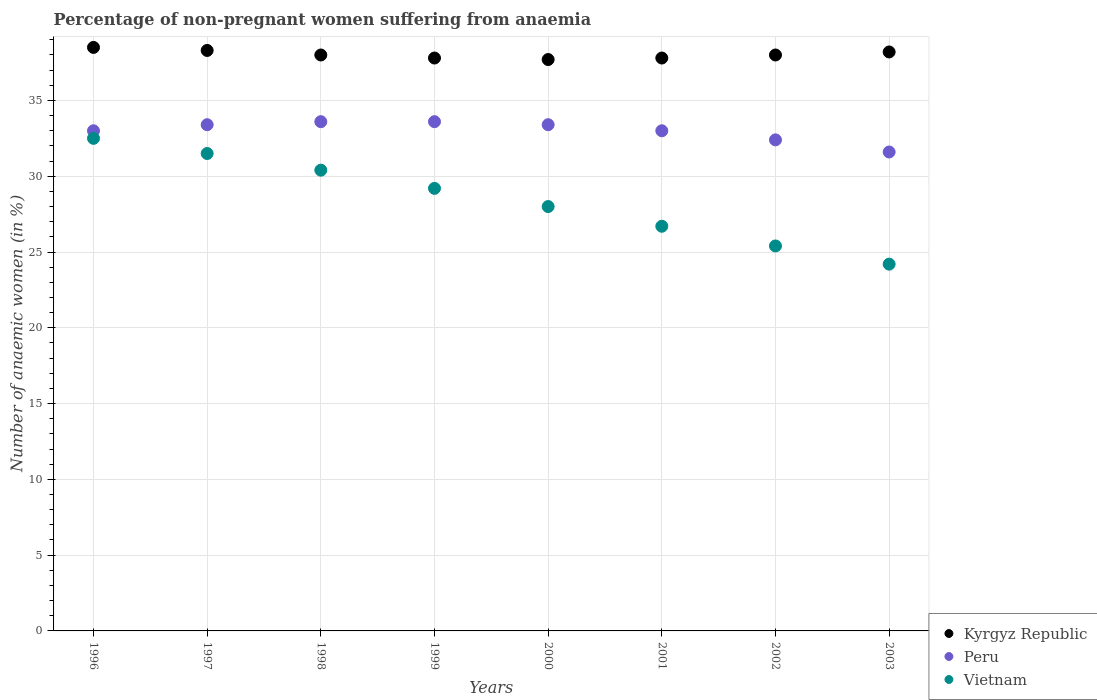How many different coloured dotlines are there?
Provide a succinct answer. 3. What is the percentage of non-pregnant women suffering from anaemia in Kyrgyz Republic in 1996?
Offer a very short reply. 38.5. Across all years, what is the maximum percentage of non-pregnant women suffering from anaemia in Kyrgyz Republic?
Provide a short and direct response. 38.5. Across all years, what is the minimum percentage of non-pregnant women suffering from anaemia in Peru?
Make the answer very short. 31.6. In which year was the percentage of non-pregnant women suffering from anaemia in Vietnam maximum?
Offer a very short reply. 1996. In which year was the percentage of non-pregnant women suffering from anaemia in Peru minimum?
Your answer should be very brief. 2003. What is the total percentage of non-pregnant women suffering from anaemia in Kyrgyz Republic in the graph?
Your answer should be very brief. 304.3. What is the difference between the percentage of non-pregnant women suffering from anaemia in Vietnam in 1998 and that in 2003?
Make the answer very short. 6.2. What is the average percentage of non-pregnant women suffering from anaemia in Kyrgyz Republic per year?
Your response must be concise. 38.04. In the year 1997, what is the difference between the percentage of non-pregnant women suffering from anaemia in Peru and percentage of non-pregnant women suffering from anaemia in Kyrgyz Republic?
Ensure brevity in your answer.  -4.9. In how many years, is the percentage of non-pregnant women suffering from anaemia in Kyrgyz Republic greater than 23 %?
Keep it short and to the point. 8. What is the ratio of the percentage of non-pregnant women suffering from anaemia in Peru in 2000 to that in 2001?
Your response must be concise. 1.01. Is the percentage of non-pregnant women suffering from anaemia in Kyrgyz Republic in 2001 less than that in 2002?
Your answer should be very brief. Yes. Is the difference between the percentage of non-pregnant women suffering from anaemia in Peru in 1997 and 2001 greater than the difference between the percentage of non-pregnant women suffering from anaemia in Kyrgyz Republic in 1997 and 2001?
Ensure brevity in your answer.  No. What is the difference between the highest and the second highest percentage of non-pregnant women suffering from anaemia in Kyrgyz Republic?
Provide a short and direct response. 0.2. What is the difference between the highest and the lowest percentage of non-pregnant women suffering from anaemia in Peru?
Ensure brevity in your answer.  2. In how many years, is the percentage of non-pregnant women suffering from anaemia in Peru greater than the average percentage of non-pregnant women suffering from anaemia in Peru taken over all years?
Provide a short and direct response. 4. Is it the case that in every year, the sum of the percentage of non-pregnant women suffering from anaemia in Peru and percentage of non-pregnant women suffering from anaemia in Vietnam  is greater than the percentage of non-pregnant women suffering from anaemia in Kyrgyz Republic?
Offer a terse response. Yes. Does the percentage of non-pregnant women suffering from anaemia in Peru monotonically increase over the years?
Your answer should be very brief. No. What is the difference between two consecutive major ticks on the Y-axis?
Offer a terse response. 5. Are the values on the major ticks of Y-axis written in scientific E-notation?
Offer a very short reply. No. Does the graph contain any zero values?
Offer a terse response. No. Does the graph contain grids?
Keep it short and to the point. Yes. Where does the legend appear in the graph?
Provide a succinct answer. Bottom right. How many legend labels are there?
Offer a very short reply. 3. What is the title of the graph?
Your answer should be compact. Percentage of non-pregnant women suffering from anaemia. What is the label or title of the X-axis?
Your response must be concise. Years. What is the label or title of the Y-axis?
Your response must be concise. Number of anaemic women (in %). What is the Number of anaemic women (in %) in Kyrgyz Republic in 1996?
Make the answer very short. 38.5. What is the Number of anaemic women (in %) of Vietnam in 1996?
Offer a terse response. 32.5. What is the Number of anaemic women (in %) in Kyrgyz Republic in 1997?
Offer a very short reply. 38.3. What is the Number of anaemic women (in %) of Peru in 1997?
Ensure brevity in your answer.  33.4. What is the Number of anaemic women (in %) in Vietnam in 1997?
Make the answer very short. 31.5. What is the Number of anaemic women (in %) in Peru in 1998?
Offer a very short reply. 33.6. What is the Number of anaemic women (in %) in Vietnam in 1998?
Provide a short and direct response. 30.4. What is the Number of anaemic women (in %) of Kyrgyz Republic in 1999?
Offer a terse response. 37.8. What is the Number of anaemic women (in %) in Peru in 1999?
Make the answer very short. 33.6. What is the Number of anaemic women (in %) in Vietnam in 1999?
Provide a succinct answer. 29.2. What is the Number of anaemic women (in %) of Kyrgyz Republic in 2000?
Your answer should be very brief. 37.7. What is the Number of anaemic women (in %) in Peru in 2000?
Your answer should be very brief. 33.4. What is the Number of anaemic women (in %) in Kyrgyz Republic in 2001?
Provide a short and direct response. 37.8. What is the Number of anaemic women (in %) of Peru in 2001?
Your response must be concise. 33. What is the Number of anaemic women (in %) of Vietnam in 2001?
Your response must be concise. 26.7. What is the Number of anaemic women (in %) of Kyrgyz Republic in 2002?
Give a very brief answer. 38. What is the Number of anaemic women (in %) of Peru in 2002?
Give a very brief answer. 32.4. What is the Number of anaemic women (in %) in Vietnam in 2002?
Provide a short and direct response. 25.4. What is the Number of anaemic women (in %) in Kyrgyz Republic in 2003?
Your answer should be compact. 38.2. What is the Number of anaemic women (in %) of Peru in 2003?
Offer a very short reply. 31.6. What is the Number of anaemic women (in %) of Vietnam in 2003?
Your answer should be very brief. 24.2. Across all years, what is the maximum Number of anaemic women (in %) of Kyrgyz Republic?
Make the answer very short. 38.5. Across all years, what is the maximum Number of anaemic women (in %) in Peru?
Provide a succinct answer. 33.6. Across all years, what is the maximum Number of anaemic women (in %) of Vietnam?
Give a very brief answer. 32.5. Across all years, what is the minimum Number of anaemic women (in %) in Kyrgyz Republic?
Make the answer very short. 37.7. Across all years, what is the minimum Number of anaemic women (in %) in Peru?
Provide a short and direct response. 31.6. Across all years, what is the minimum Number of anaemic women (in %) in Vietnam?
Give a very brief answer. 24.2. What is the total Number of anaemic women (in %) of Kyrgyz Republic in the graph?
Ensure brevity in your answer.  304.3. What is the total Number of anaemic women (in %) in Peru in the graph?
Make the answer very short. 264. What is the total Number of anaemic women (in %) in Vietnam in the graph?
Your answer should be compact. 227.9. What is the difference between the Number of anaemic women (in %) in Kyrgyz Republic in 1996 and that in 1997?
Your response must be concise. 0.2. What is the difference between the Number of anaemic women (in %) of Peru in 1996 and that in 1997?
Offer a terse response. -0.4. What is the difference between the Number of anaemic women (in %) in Vietnam in 1996 and that in 1999?
Keep it short and to the point. 3.3. What is the difference between the Number of anaemic women (in %) in Kyrgyz Republic in 1996 and that in 2000?
Your response must be concise. 0.8. What is the difference between the Number of anaemic women (in %) in Peru in 1996 and that in 2001?
Make the answer very short. 0. What is the difference between the Number of anaemic women (in %) in Kyrgyz Republic in 1996 and that in 2002?
Your answer should be very brief. 0.5. What is the difference between the Number of anaemic women (in %) of Peru in 1996 and that in 2003?
Provide a succinct answer. 1.4. What is the difference between the Number of anaemic women (in %) in Kyrgyz Republic in 1997 and that in 1998?
Offer a very short reply. 0.3. What is the difference between the Number of anaemic women (in %) in Vietnam in 1997 and that in 1998?
Your answer should be compact. 1.1. What is the difference between the Number of anaemic women (in %) of Vietnam in 1997 and that in 1999?
Provide a succinct answer. 2.3. What is the difference between the Number of anaemic women (in %) of Kyrgyz Republic in 1997 and that in 2000?
Offer a very short reply. 0.6. What is the difference between the Number of anaemic women (in %) in Vietnam in 1997 and that in 2001?
Ensure brevity in your answer.  4.8. What is the difference between the Number of anaemic women (in %) in Peru in 1997 and that in 2002?
Offer a very short reply. 1. What is the difference between the Number of anaemic women (in %) in Peru in 1997 and that in 2003?
Provide a short and direct response. 1.8. What is the difference between the Number of anaemic women (in %) in Vietnam in 1997 and that in 2003?
Provide a succinct answer. 7.3. What is the difference between the Number of anaemic women (in %) in Kyrgyz Republic in 1998 and that in 1999?
Provide a succinct answer. 0.2. What is the difference between the Number of anaemic women (in %) of Kyrgyz Republic in 1998 and that in 2000?
Your answer should be compact. 0.3. What is the difference between the Number of anaemic women (in %) of Kyrgyz Republic in 1998 and that in 2001?
Offer a very short reply. 0.2. What is the difference between the Number of anaemic women (in %) in Vietnam in 1998 and that in 2001?
Keep it short and to the point. 3.7. What is the difference between the Number of anaemic women (in %) in Kyrgyz Republic in 1998 and that in 2002?
Provide a short and direct response. 0. What is the difference between the Number of anaemic women (in %) of Peru in 1998 and that in 2002?
Your response must be concise. 1.2. What is the difference between the Number of anaemic women (in %) in Vietnam in 1998 and that in 2002?
Your answer should be very brief. 5. What is the difference between the Number of anaemic women (in %) in Vietnam in 1998 and that in 2003?
Your answer should be very brief. 6.2. What is the difference between the Number of anaemic women (in %) of Peru in 1999 and that in 2000?
Your answer should be compact. 0.2. What is the difference between the Number of anaemic women (in %) in Peru in 1999 and that in 2001?
Keep it short and to the point. 0.6. What is the difference between the Number of anaemic women (in %) in Vietnam in 1999 and that in 2001?
Offer a terse response. 2.5. What is the difference between the Number of anaemic women (in %) of Vietnam in 1999 and that in 2002?
Ensure brevity in your answer.  3.8. What is the difference between the Number of anaemic women (in %) of Kyrgyz Republic in 1999 and that in 2003?
Your answer should be very brief. -0.4. What is the difference between the Number of anaemic women (in %) in Vietnam in 1999 and that in 2003?
Ensure brevity in your answer.  5. What is the difference between the Number of anaemic women (in %) of Kyrgyz Republic in 2000 and that in 2001?
Provide a short and direct response. -0.1. What is the difference between the Number of anaemic women (in %) in Vietnam in 2000 and that in 2001?
Offer a terse response. 1.3. What is the difference between the Number of anaemic women (in %) in Kyrgyz Republic in 2000 and that in 2002?
Your answer should be very brief. -0.3. What is the difference between the Number of anaemic women (in %) of Peru in 2000 and that in 2002?
Make the answer very short. 1. What is the difference between the Number of anaemic women (in %) of Kyrgyz Republic in 2000 and that in 2003?
Your answer should be very brief. -0.5. What is the difference between the Number of anaemic women (in %) in Peru in 2000 and that in 2003?
Offer a very short reply. 1.8. What is the difference between the Number of anaemic women (in %) in Peru in 2001 and that in 2003?
Provide a succinct answer. 1.4. What is the difference between the Number of anaemic women (in %) in Vietnam in 2001 and that in 2003?
Your answer should be compact. 2.5. What is the difference between the Number of anaemic women (in %) in Kyrgyz Republic in 2002 and that in 2003?
Keep it short and to the point. -0.2. What is the difference between the Number of anaemic women (in %) in Peru in 2002 and that in 2003?
Offer a terse response. 0.8. What is the difference between the Number of anaemic women (in %) of Peru in 1996 and the Number of anaemic women (in %) of Vietnam in 1997?
Provide a succinct answer. 1.5. What is the difference between the Number of anaemic women (in %) in Kyrgyz Republic in 1996 and the Number of anaemic women (in %) in Peru in 1998?
Ensure brevity in your answer.  4.9. What is the difference between the Number of anaemic women (in %) of Kyrgyz Republic in 1996 and the Number of anaemic women (in %) of Vietnam in 1998?
Make the answer very short. 8.1. What is the difference between the Number of anaemic women (in %) of Peru in 1996 and the Number of anaemic women (in %) of Vietnam in 1998?
Give a very brief answer. 2.6. What is the difference between the Number of anaemic women (in %) of Kyrgyz Republic in 1996 and the Number of anaemic women (in %) of Peru in 1999?
Ensure brevity in your answer.  4.9. What is the difference between the Number of anaemic women (in %) of Kyrgyz Republic in 1996 and the Number of anaemic women (in %) of Vietnam in 1999?
Offer a very short reply. 9.3. What is the difference between the Number of anaemic women (in %) in Peru in 1996 and the Number of anaemic women (in %) in Vietnam in 1999?
Your answer should be compact. 3.8. What is the difference between the Number of anaemic women (in %) of Peru in 1996 and the Number of anaemic women (in %) of Vietnam in 2000?
Your answer should be compact. 5. What is the difference between the Number of anaemic women (in %) in Kyrgyz Republic in 1996 and the Number of anaemic women (in %) in Peru in 2001?
Keep it short and to the point. 5.5. What is the difference between the Number of anaemic women (in %) of Peru in 1996 and the Number of anaemic women (in %) of Vietnam in 2001?
Your response must be concise. 6.3. What is the difference between the Number of anaemic women (in %) in Peru in 1996 and the Number of anaemic women (in %) in Vietnam in 2002?
Give a very brief answer. 7.6. What is the difference between the Number of anaemic women (in %) of Kyrgyz Republic in 1996 and the Number of anaemic women (in %) of Peru in 2003?
Provide a short and direct response. 6.9. What is the difference between the Number of anaemic women (in %) of Kyrgyz Republic in 1996 and the Number of anaemic women (in %) of Vietnam in 2003?
Keep it short and to the point. 14.3. What is the difference between the Number of anaemic women (in %) of Kyrgyz Republic in 1997 and the Number of anaemic women (in %) of Vietnam in 1998?
Provide a short and direct response. 7.9. What is the difference between the Number of anaemic women (in %) of Peru in 1997 and the Number of anaemic women (in %) of Vietnam in 1998?
Keep it short and to the point. 3. What is the difference between the Number of anaemic women (in %) of Kyrgyz Republic in 1997 and the Number of anaemic women (in %) of Peru in 1999?
Give a very brief answer. 4.7. What is the difference between the Number of anaemic women (in %) of Peru in 1997 and the Number of anaemic women (in %) of Vietnam in 1999?
Make the answer very short. 4.2. What is the difference between the Number of anaemic women (in %) of Kyrgyz Republic in 1997 and the Number of anaemic women (in %) of Vietnam in 2000?
Provide a succinct answer. 10.3. What is the difference between the Number of anaemic women (in %) of Kyrgyz Republic in 1997 and the Number of anaemic women (in %) of Peru in 2001?
Your response must be concise. 5.3. What is the difference between the Number of anaemic women (in %) of Kyrgyz Republic in 1997 and the Number of anaemic women (in %) of Vietnam in 2001?
Make the answer very short. 11.6. What is the difference between the Number of anaemic women (in %) of Peru in 1997 and the Number of anaemic women (in %) of Vietnam in 2001?
Make the answer very short. 6.7. What is the difference between the Number of anaemic women (in %) of Peru in 1997 and the Number of anaemic women (in %) of Vietnam in 2002?
Give a very brief answer. 8. What is the difference between the Number of anaemic women (in %) of Kyrgyz Republic in 1997 and the Number of anaemic women (in %) of Peru in 2003?
Give a very brief answer. 6.7. What is the difference between the Number of anaemic women (in %) in Kyrgyz Republic in 1997 and the Number of anaemic women (in %) in Vietnam in 2003?
Ensure brevity in your answer.  14.1. What is the difference between the Number of anaemic women (in %) in Peru in 1997 and the Number of anaemic women (in %) in Vietnam in 2003?
Your response must be concise. 9.2. What is the difference between the Number of anaemic women (in %) in Kyrgyz Republic in 1998 and the Number of anaemic women (in %) in Peru in 1999?
Ensure brevity in your answer.  4.4. What is the difference between the Number of anaemic women (in %) of Peru in 1998 and the Number of anaemic women (in %) of Vietnam in 2000?
Keep it short and to the point. 5.6. What is the difference between the Number of anaemic women (in %) of Kyrgyz Republic in 1998 and the Number of anaemic women (in %) of Peru in 2001?
Ensure brevity in your answer.  5. What is the difference between the Number of anaemic women (in %) in Kyrgyz Republic in 1998 and the Number of anaemic women (in %) in Peru in 2002?
Your answer should be very brief. 5.6. What is the difference between the Number of anaemic women (in %) of Kyrgyz Republic in 1998 and the Number of anaemic women (in %) of Vietnam in 2002?
Your answer should be very brief. 12.6. What is the difference between the Number of anaemic women (in %) of Peru in 1998 and the Number of anaemic women (in %) of Vietnam in 2002?
Keep it short and to the point. 8.2. What is the difference between the Number of anaemic women (in %) in Kyrgyz Republic in 1998 and the Number of anaemic women (in %) in Vietnam in 2003?
Keep it short and to the point. 13.8. What is the difference between the Number of anaemic women (in %) of Kyrgyz Republic in 1999 and the Number of anaemic women (in %) of Peru in 2000?
Give a very brief answer. 4.4. What is the difference between the Number of anaemic women (in %) of Kyrgyz Republic in 1999 and the Number of anaemic women (in %) of Vietnam in 2000?
Offer a very short reply. 9.8. What is the difference between the Number of anaemic women (in %) of Kyrgyz Republic in 1999 and the Number of anaemic women (in %) of Peru in 2001?
Ensure brevity in your answer.  4.8. What is the difference between the Number of anaemic women (in %) in Peru in 1999 and the Number of anaemic women (in %) in Vietnam in 2001?
Your response must be concise. 6.9. What is the difference between the Number of anaemic women (in %) of Kyrgyz Republic in 1999 and the Number of anaemic women (in %) of Vietnam in 2002?
Keep it short and to the point. 12.4. What is the difference between the Number of anaemic women (in %) of Peru in 2000 and the Number of anaemic women (in %) of Vietnam in 2001?
Provide a succinct answer. 6.7. What is the difference between the Number of anaemic women (in %) of Kyrgyz Republic in 2000 and the Number of anaemic women (in %) of Peru in 2002?
Provide a succinct answer. 5.3. What is the difference between the Number of anaemic women (in %) in Kyrgyz Republic in 2000 and the Number of anaemic women (in %) in Vietnam in 2002?
Your answer should be compact. 12.3. What is the difference between the Number of anaemic women (in %) in Kyrgyz Republic in 2001 and the Number of anaemic women (in %) in Peru in 2002?
Your answer should be very brief. 5.4. What is the difference between the Number of anaemic women (in %) of Kyrgyz Republic in 2001 and the Number of anaemic women (in %) of Vietnam in 2002?
Keep it short and to the point. 12.4. What is the difference between the Number of anaemic women (in %) of Peru in 2001 and the Number of anaemic women (in %) of Vietnam in 2002?
Your answer should be very brief. 7.6. What is the difference between the Number of anaemic women (in %) of Kyrgyz Republic in 2001 and the Number of anaemic women (in %) of Peru in 2003?
Ensure brevity in your answer.  6.2. What is the difference between the Number of anaemic women (in %) in Kyrgyz Republic in 2001 and the Number of anaemic women (in %) in Vietnam in 2003?
Ensure brevity in your answer.  13.6. What is the average Number of anaemic women (in %) of Kyrgyz Republic per year?
Provide a short and direct response. 38.04. What is the average Number of anaemic women (in %) in Vietnam per year?
Your answer should be very brief. 28.49. In the year 1997, what is the difference between the Number of anaemic women (in %) in Kyrgyz Republic and Number of anaemic women (in %) in Peru?
Your answer should be very brief. 4.9. In the year 1997, what is the difference between the Number of anaemic women (in %) in Kyrgyz Republic and Number of anaemic women (in %) in Vietnam?
Offer a very short reply. 6.8. In the year 1998, what is the difference between the Number of anaemic women (in %) in Kyrgyz Republic and Number of anaemic women (in %) in Peru?
Provide a short and direct response. 4.4. In the year 1998, what is the difference between the Number of anaemic women (in %) in Kyrgyz Republic and Number of anaemic women (in %) in Vietnam?
Offer a terse response. 7.6. In the year 1998, what is the difference between the Number of anaemic women (in %) in Peru and Number of anaemic women (in %) in Vietnam?
Offer a very short reply. 3.2. In the year 2000, what is the difference between the Number of anaemic women (in %) of Kyrgyz Republic and Number of anaemic women (in %) of Vietnam?
Offer a terse response. 9.7. In the year 2000, what is the difference between the Number of anaemic women (in %) of Peru and Number of anaemic women (in %) of Vietnam?
Your answer should be compact. 5.4. In the year 2001, what is the difference between the Number of anaemic women (in %) of Kyrgyz Republic and Number of anaemic women (in %) of Peru?
Provide a succinct answer. 4.8. In the year 2001, what is the difference between the Number of anaemic women (in %) in Kyrgyz Republic and Number of anaemic women (in %) in Vietnam?
Keep it short and to the point. 11.1. In the year 2003, what is the difference between the Number of anaemic women (in %) in Kyrgyz Republic and Number of anaemic women (in %) in Vietnam?
Make the answer very short. 14. In the year 2003, what is the difference between the Number of anaemic women (in %) of Peru and Number of anaemic women (in %) of Vietnam?
Provide a succinct answer. 7.4. What is the ratio of the Number of anaemic women (in %) of Kyrgyz Republic in 1996 to that in 1997?
Make the answer very short. 1.01. What is the ratio of the Number of anaemic women (in %) in Vietnam in 1996 to that in 1997?
Offer a very short reply. 1.03. What is the ratio of the Number of anaemic women (in %) of Kyrgyz Republic in 1996 to that in 1998?
Offer a very short reply. 1.01. What is the ratio of the Number of anaemic women (in %) in Peru in 1996 to that in 1998?
Provide a short and direct response. 0.98. What is the ratio of the Number of anaemic women (in %) in Vietnam in 1996 to that in 1998?
Your answer should be very brief. 1.07. What is the ratio of the Number of anaemic women (in %) of Kyrgyz Republic in 1996 to that in 1999?
Offer a terse response. 1.02. What is the ratio of the Number of anaemic women (in %) in Peru in 1996 to that in 1999?
Give a very brief answer. 0.98. What is the ratio of the Number of anaemic women (in %) of Vietnam in 1996 to that in 1999?
Your answer should be compact. 1.11. What is the ratio of the Number of anaemic women (in %) in Kyrgyz Republic in 1996 to that in 2000?
Provide a short and direct response. 1.02. What is the ratio of the Number of anaemic women (in %) of Peru in 1996 to that in 2000?
Offer a terse response. 0.99. What is the ratio of the Number of anaemic women (in %) of Vietnam in 1996 to that in 2000?
Your answer should be very brief. 1.16. What is the ratio of the Number of anaemic women (in %) of Kyrgyz Republic in 1996 to that in 2001?
Your response must be concise. 1.02. What is the ratio of the Number of anaemic women (in %) in Vietnam in 1996 to that in 2001?
Offer a terse response. 1.22. What is the ratio of the Number of anaemic women (in %) in Kyrgyz Republic in 1996 to that in 2002?
Give a very brief answer. 1.01. What is the ratio of the Number of anaemic women (in %) in Peru in 1996 to that in 2002?
Your response must be concise. 1.02. What is the ratio of the Number of anaemic women (in %) of Vietnam in 1996 to that in 2002?
Provide a succinct answer. 1.28. What is the ratio of the Number of anaemic women (in %) in Kyrgyz Republic in 1996 to that in 2003?
Offer a very short reply. 1.01. What is the ratio of the Number of anaemic women (in %) of Peru in 1996 to that in 2003?
Keep it short and to the point. 1.04. What is the ratio of the Number of anaemic women (in %) of Vietnam in 1996 to that in 2003?
Your answer should be compact. 1.34. What is the ratio of the Number of anaemic women (in %) of Kyrgyz Republic in 1997 to that in 1998?
Provide a short and direct response. 1.01. What is the ratio of the Number of anaemic women (in %) in Vietnam in 1997 to that in 1998?
Make the answer very short. 1.04. What is the ratio of the Number of anaemic women (in %) of Kyrgyz Republic in 1997 to that in 1999?
Provide a short and direct response. 1.01. What is the ratio of the Number of anaemic women (in %) in Peru in 1997 to that in 1999?
Your response must be concise. 0.99. What is the ratio of the Number of anaemic women (in %) of Vietnam in 1997 to that in 1999?
Ensure brevity in your answer.  1.08. What is the ratio of the Number of anaemic women (in %) of Kyrgyz Republic in 1997 to that in 2000?
Your answer should be compact. 1.02. What is the ratio of the Number of anaemic women (in %) in Kyrgyz Republic in 1997 to that in 2001?
Make the answer very short. 1.01. What is the ratio of the Number of anaemic women (in %) of Peru in 1997 to that in 2001?
Offer a terse response. 1.01. What is the ratio of the Number of anaemic women (in %) in Vietnam in 1997 to that in 2001?
Make the answer very short. 1.18. What is the ratio of the Number of anaemic women (in %) in Kyrgyz Republic in 1997 to that in 2002?
Provide a short and direct response. 1.01. What is the ratio of the Number of anaemic women (in %) in Peru in 1997 to that in 2002?
Provide a short and direct response. 1.03. What is the ratio of the Number of anaemic women (in %) in Vietnam in 1997 to that in 2002?
Provide a short and direct response. 1.24. What is the ratio of the Number of anaemic women (in %) of Peru in 1997 to that in 2003?
Give a very brief answer. 1.06. What is the ratio of the Number of anaemic women (in %) of Vietnam in 1997 to that in 2003?
Your answer should be compact. 1.3. What is the ratio of the Number of anaemic women (in %) in Vietnam in 1998 to that in 1999?
Your response must be concise. 1.04. What is the ratio of the Number of anaemic women (in %) of Vietnam in 1998 to that in 2000?
Make the answer very short. 1.09. What is the ratio of the Number of anaemic women (in %) of Kyrgyz Republic in 1998 to that in 2001?
Your answer should be compact. 1.01. What is the ratio of the Number of anaemic women (in %) of Peru in 1998 to that in 2001?
Keep it short and to the point. 1.02. What is the ratio of the Number of anaemic women (in %) in Vietnam in 1998 to that in 2001?
Your answer should be compact. 1.14. What is the ratio of the Number of anaemic women (in %) in Vietnam in 1998 to that in 2002?
Provide a short and direct response. 1.2. What is the ratio of the Number of anaemic women (in %) of Peru in 1998 to that in 2003?
Provide a succinct answer. 1.06. What is the ratio of the Number of anaemic women (in %) in Vietnam in 1998 to that in 2003?
Ensure brevity in your answer.  1.26. What is the ratio of the Number of anaemic women (in %) in Peru in 1999 to that in 2000?
Give a very brief answer. 1.01. What is the ratio of the Number of anaemic women (in %) in Vietnam in 1999 to that in 2000?
Ensure brevity in your answer.  1.04. What is the ratio of the Number of anaemic women (in %) in Peru in 1999 to that in 2001?
Your response must be concise. 1.02. What is the ratio of the Number of anaemic women (in %) in Vietnam in 1999 to that in 2001?
Ensure brevity in your answer.  1.09. What is the ratio of the Number of anaemic women (in %) in Peru in 1999 to that in 2002?
Your answer should be very brief. 1.04. What is the ratio of the Number of anaemic women (in %) of Vietnam in 1999 to that in 2002?
Keep it short and to the point. 1.15. What is the ratio of the Number of anaemic women (in %) in Kyrgyz Republic in 1999 to that in 2003?
Provide a succinct answer. 0.99. What is the ratio of the Number of anaemic women (in %) in Peru in 1999 to that in 2003?
Keep it short and to the point. 1.06. What is the ratio of the Number of anaemic women (in %) of Vietnam in 1999 to that in 2003?
Your answer should be very brief. 1.21. What is the ratio of the Number of anaemic women (in %) in Peru in 2000 to that in 2001?
Offer a terse response. 1.01. What is the ratio of the Number of anaemic women (in %) in Vietnam in 2000 to that in 2001?
Your answer should be compact. 1.05. What is the ratio of the Number of anaemic women (in %) of Kyrgyz Republic in 2000 to that in 2002?
Keep it short and to the point. 0.99. What is the ratio of the Number of anaemic women (in %) of Peru in 2000 to that in 2002?
Offer a terse response. 1.03. What is the ratio of the Number of anaemic women (in %) of Vietnam in 2000 to that in 2002?
Your response must be concise. 1.1. What is the ratio of the Number of anaemic women (in %) of Kyrgyz Republic in 2000 to that in 2003?
Give a very brief answer. 0.99. What is the ratio of the Number of anaemic women (in %) of Peru in 2000 to that in 2003?
Your answer should be very brief. 1.06. What is the ratio of the Number of anaemic women (in %) of Vietnam in 2000 to that in 2003?
Provide a short and direct response. 1.16. What is the ratio of the Number of anaemic women (in %) of Kyrgyz Republic in 2001 to that in 2002?
Offer a terse response. 0.99. What is the ratio of the Number of anaemic women (in %) of Peru in 2001 to that in 2002?
Ensure brevity in your answer.  1.02. What is the ratio of the Number of anaemic women (in %) of Vietnam in 2001 to that in 2002?
Offer a very short reply. 1.05. What is the ratio of the Number of anaemic women (in %) of Kyrgyz Republic in 2001 to that in 2003?
Give a very brief answer. 0.99. What is the ratio of the Number of anaemic women (in %) of Peru in 2001 to that in 2003?
Your response must be concise. 1.04. What is the ratio of the Number of anaemic women (in %) of Vietnam in 2001 to that in 2003?
Offer a very short reply. 1.1. What is the ratio of the Number of anaemic women (in %) of Kyrgyz Republic in 2002 to that in 2003?
Your answer should be very brief. 0.99. What is the ratio of the Number of anaemic women (in %) of Peru in 2002 to that in 2003?
Your response must be concise. 1.03. What is the ratio of the Number of anaemic women (in %) in Vietnam in 2002 to that in 2003?
Provide a short and direct response. 1.05. What is the difference between the highest and the second highest Number of anaemic women (in %) of Kyrgyz Republic?
Your answer should be very brief. 0.2. What is the difference between the highest and the lowest Number of anaemic women (in %) of Kyrgyz Republic?
Offer a terse response. 0.8. What is the difference between the highest and the lowest Number of anaemic women (in %) of Peru?
Provide a short and direct response. 2. What is the difference between the highest and the lowest Number of anaemic women (in %) of Vietnam?
Your answer should be compact. 8.3. 